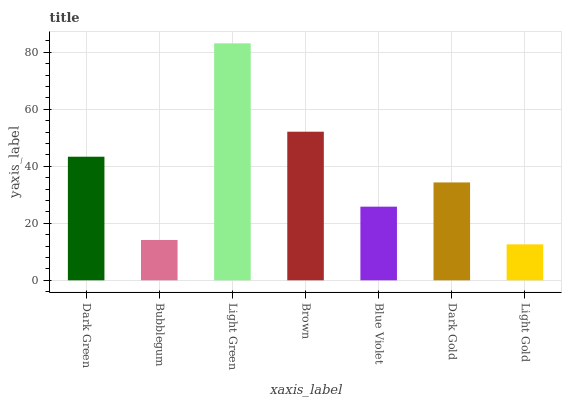Is Light Gold the minimum?
Answer yes or no. Yes. Is Light Green the maximum?
Answer yes or no. Yes. Is Bubblegum the minimum?
Answer yes or no. No. Is Bubblegum the maximum?
Answer yes or no. No. Is Dark Green greater than Bubblegum?
Answer yes or no. Yes. Is Bubblegum less than Dark Green?
Answer yes or no. Yes. Is Bubblegum greater than Dark Green?
Answer yes or no. No. Is Dark Green less than Bubblegum?
Answer yes or no. No. Is Dark Gold the high median?
Answer yes or no. Yes. Is Dark Gold the low median?
Answer yes or no. Yes. Is Light Green the high median?
Answer yes or no. No. Is Light Green the low median?
Answer yes or no. No. 